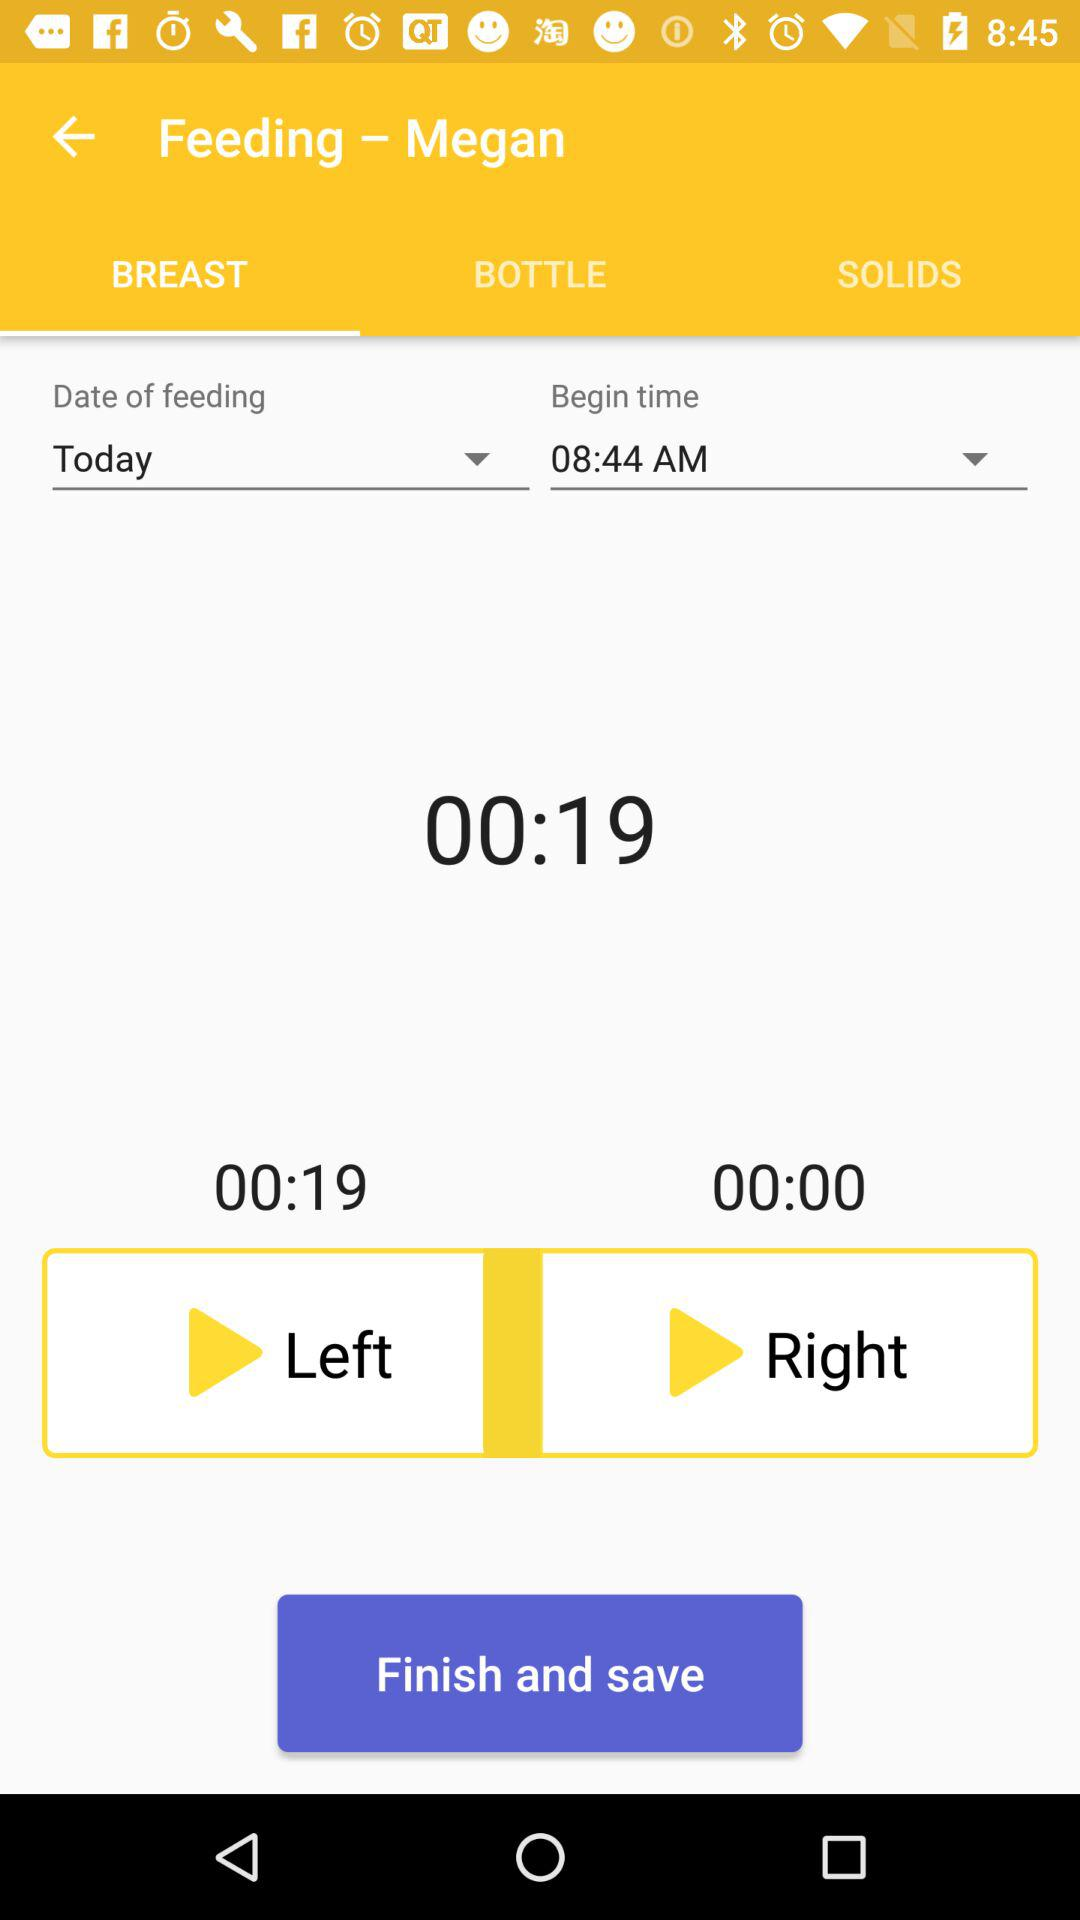What is the selected tab? The selected tab is "BREAST". 